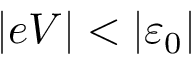Convert formula to latex. <formula><loc_0><loc_0><loc_500><loc_500>| e V | < \left | \varepsilon _ { 0 } \right |</formula> 